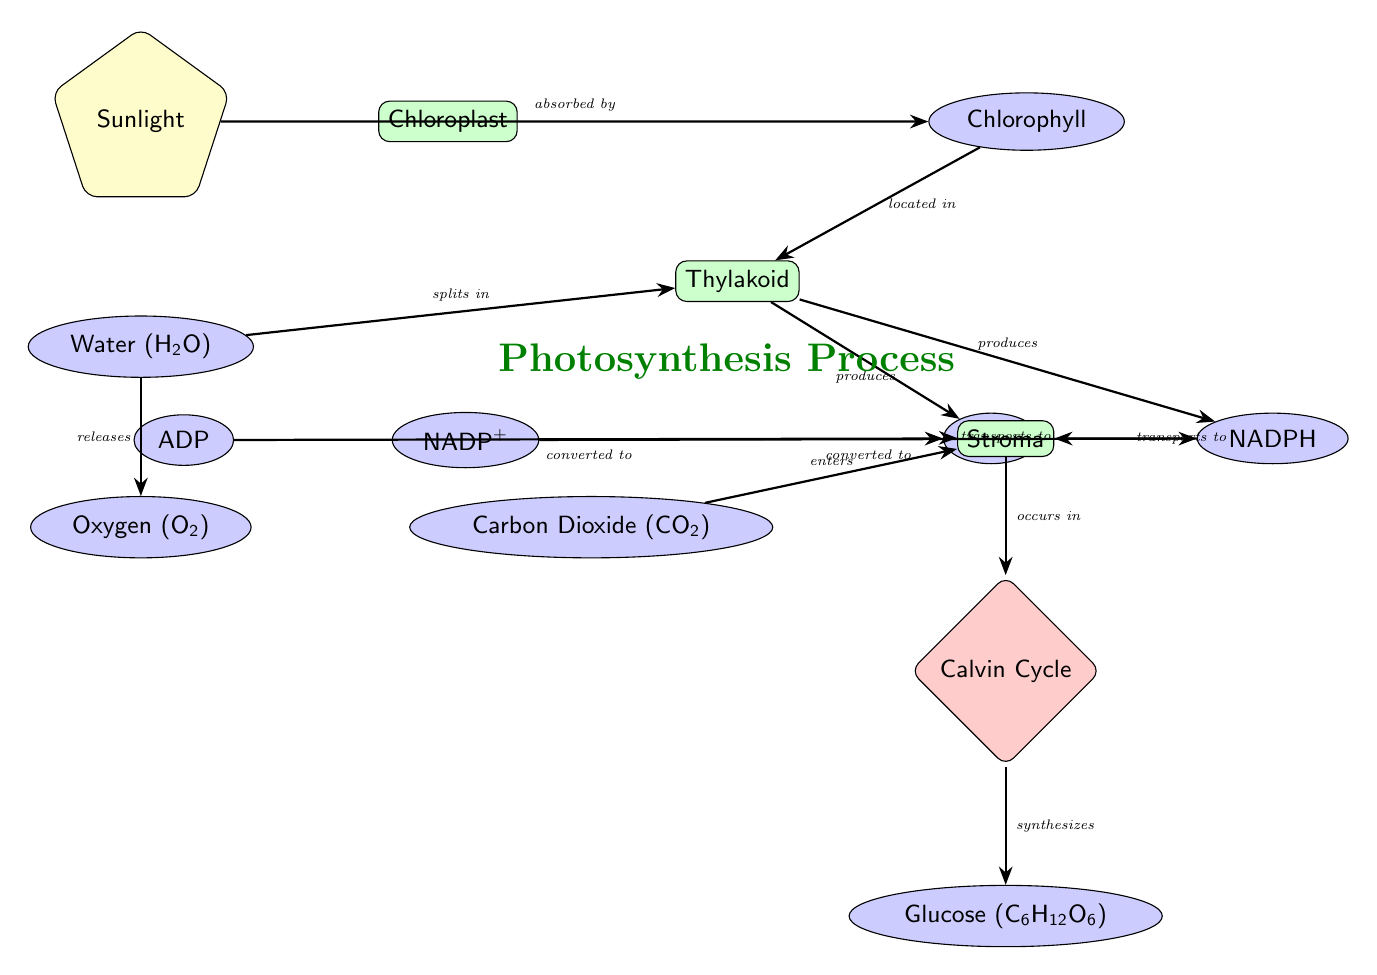What is the primary energy source for the photosynthesis process? The diagram indicates that the primary energy source for photosynthesis is Sunlight, which is depicted at the top of the diagram.
Answer: Sunlight What substance is split in the Thylakoid? According to the diagram, Water (H2O) is indicated as the substance that splits in the Thylakoid, based on the arrow labeled "splits in."
Answer: Water How many key substances are involved in the Light-Dependent reactions? By reviewing the diagram, there are a total of five key substances directly involved in the Light-Dependent reactions: Water, NADP+, ADP, ATP, and NADPH.
Answer: Five In which part of the plant does the Calvin Cycle occur? The diagram shows that the Calvin Cycle occurs in the Stroma, as indicated by the arrow leading to the Calvin Cycle node which specifies "occurs in."
Answer: Stroma What is produced as a byproduct of photosynthesis during the splitting of Water? The diagram indicates that Oxygen (O2) is released as a byproduct when Water splits, as seen from the labeled arrow "releases."
Answer: Oxygen What is the relationship between NADP+ and NADPH? The diagram shows that NADP+ is converted to NADPH, indicated by the arrow labeled "converted to," which conveys a transformation process between these two substances.
Answer: Converted to Which two products are transported to the Stroma from the Thylakoid? The diagram clearly indicates that both ATP and NADPH are transported to the Stroma from the Thylakoid, as represented by the arrows going from those nodes to Stroma.
Answer: ATP and NADPH What is the final product of the Calvin Cycle depicted in the diagram? Analyzing the diagram, the final product of the Calvin Cycle is Glucose (C6H12O6), as indicated by the last arrow labeled "synthesizes."
Answer: Glucose What are the input substances into the Calvin Cycle? The diagram illustrates that the inputs for the Calvin Cycle are NADPH and Carbon Dioxide (CO2), which enter the Stroma before the Calvin Cycle occurs.
Answer: NADPH and Carbon Dioxide 